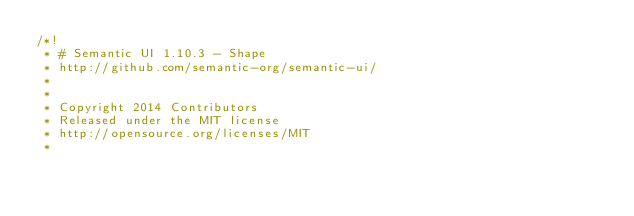Convert code to text. <code><loc_0><loc_0><loc_500><loc_500><_CSS_>/*!
 * # Semantic UI 1.10.3 - Shape
 * http://github.com/semantic-org/semantic-ui/
 *
 *
 * Copyright 2014 Contributors
 * Released under the MIT license
 * http://opensource.org/licenses/MIT
 *</code> 